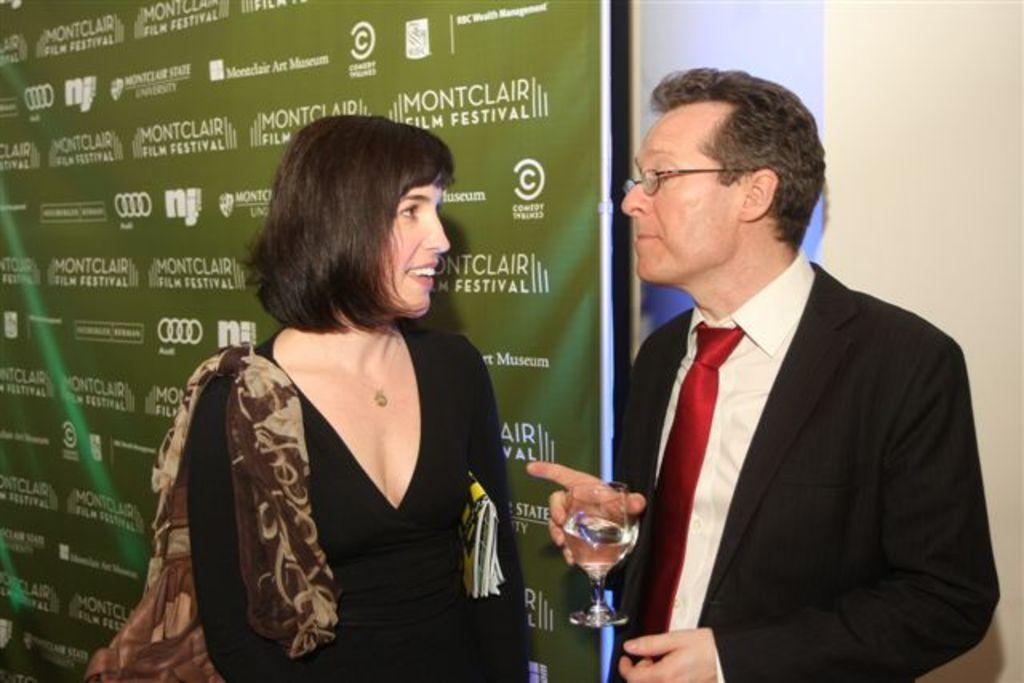What is the main subject of the image? There is a person standing in the image. What is the person holding in their hand? The person is holding a wine glass in their hand. Who is standing beside the person? There is a woman standing beside the person. What is the expression on the woman's face? The woman is smiling. What can be seen in the background of the image? There is a wall visible in the background of the image. What type of blood is visible on the wall in the image? There is no blood visible on the wall in the image. What type of office furniture can be seen in the image? There is no office furniture present in the image. 